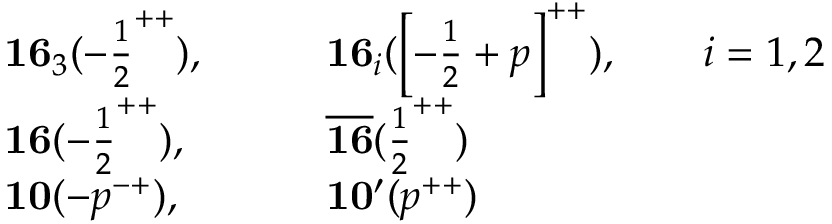Convert formula to latex. <formula><loc_0><loc_0><loc_500><loc_500>\begin{array} { l l } { { { 1 6 } _ { 3 } ( - { \frac { 1 } { 2 } } ^ { + + } ) , \quad } } & { { { 1 6 } _ { i } ( \left [ - { \frac { 1 } { 2 } } + p \right ] ^ { + + } ) , \quad i = 1 , 2 } } \\ { { { 1 6 } ( - { \frac { 1 } { 2 } } ^ { + + } ) , \quad } } & { { { \overline { 1 6 } } ( { \frac { 1 } { 2 } } ^ { + + } ) } } \\ { { { 1 0 } ( - p ^ { - + } ) , \quad } } & { { { 1 0 ^ { \prime } } ( p ^ { + + } ) } } \end{array}</formula> 